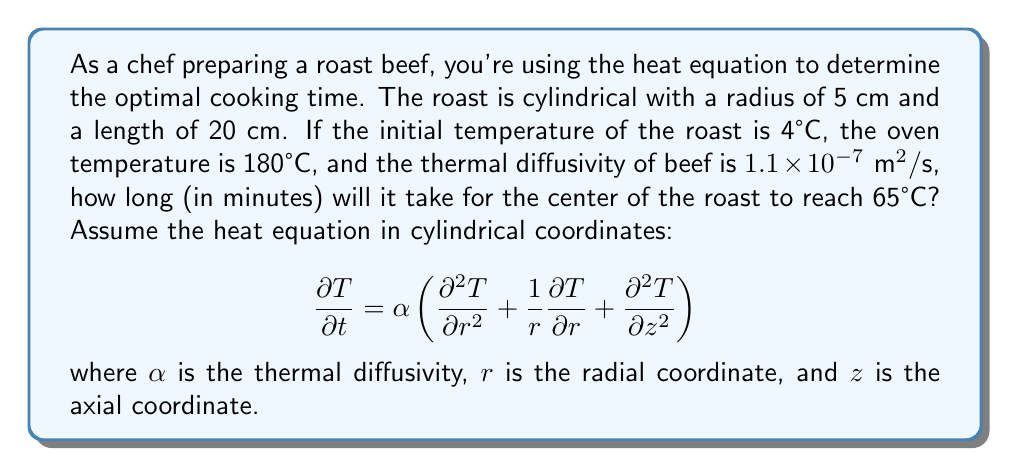Provide a solution to this math problem. To solve this problem, we'll use a simplified approach based on the heat equation:

1) First, we need to calculate the characteristic length. For a cylinder, it's given by:
   $$L_c = \frac{V}{A} = \frac{\pi r^2 h}{2\pi r h + 2\pi r^2} = \frac{r}{2 + \frac{2r}{h}}$$

   Where $r = 0.05$ m and $h = 0.2$ m
   
   $$L_c = \frac{0.05}{2 + \frac{2(0.05)}{0.2}} = 0.0192 \text{ m}$$

2) Next, we'll use the Fourier number (Fo) to estimate the cooking time. For the center to reach 65°C, we need Fo ≈ 1.5:
   $$\text{Fo} = \frac{\alpha t}{L_c^2} = 1.5$$

3) Rearranging to solve for time $t$:
   $$t = \frac{1.5 L_c^2}{\alpha}$$

4) Substituting the values:
   $$t = \frac{1.5 (0.0192 \text{ m})^2}{1.1 \times 10^{-7} \text{ m}^2/\text{s}}$$

5) Calculating:
   $$t = 5018.18 \text{ s} = 83.64 \text{ minutes}$$

Therefore, it will take approximately 84 minutes for the center of the roast to reach 65°C.
Answer: 84 minutes 